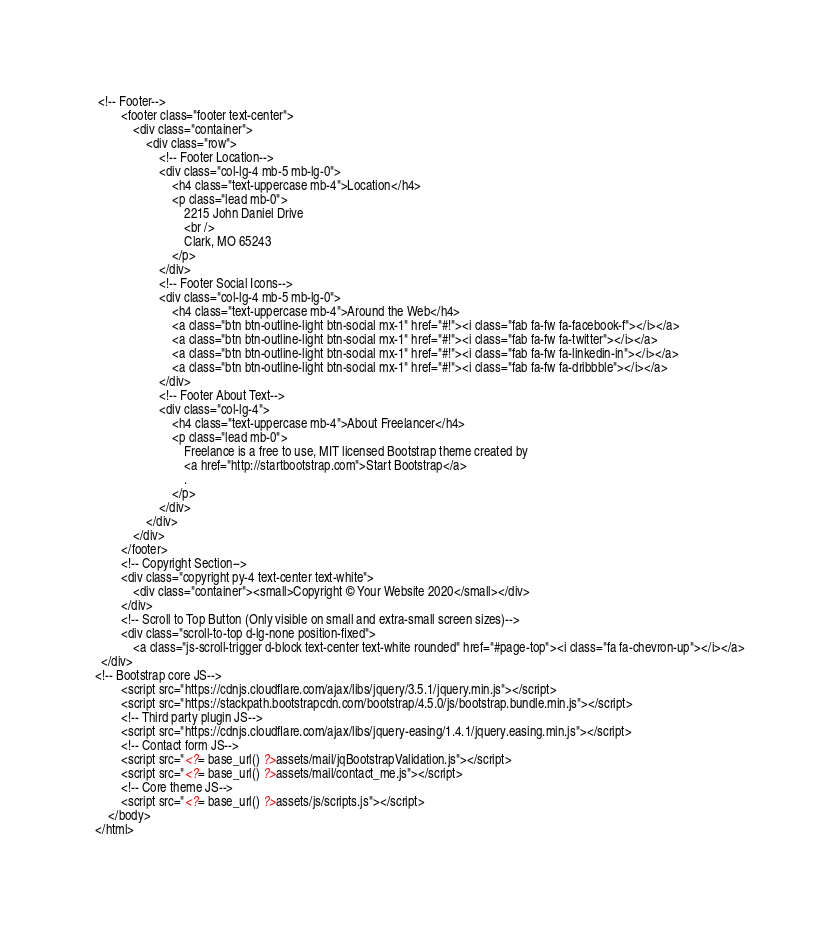Convert code to text. <code><loc_0><loc_0><loc_500><loc_500><_PHP_> <!-- Footer-->
        <footer class="footer text-center">
            <div class="container">
                <div class="row">
                    <!-- Footer Location-->
                    <div class="col-lg-4 mb-5 mb-lg-0">
                        <h4 class="text-uppercase mb-4">Location</h4>
                        <p class="lead mb-0">
                            2215 John Daniel Drive
                            <br />
                            Clark, MO 65243
                        </p>
                    </div>
                    <!-- Footer Social Icons-->
                    <div class="col-lg-4 mb-5 mb-lg-0">
                        <h4 class="text-uppercase mb-4">Around the Web</h4>
                        <a class="btn btn-outline-light btn-social mx-1" href="#!"><i class="fab fa-fw fa-facebook-f"></i></a>
                        <a class="btn btn-outline-light btn-social mx-1" href="#!"><i class="fab fa-fw fa-twitter"></i></a>
                        <a class="btn btn-outline-light btn-social mx-1" href="#!"><i class="fab fa-fw fa-linkedin-in"></i></a>
                        <a class="btn btn-outline-light btn-social mx-1" href="#!"><i class="fab fa-fw fa-dribbble"></i></a>
                    </div>
                    <!-- Footer About Text-->
                    <div class="col-lg-4">
                        <h4 class="text-uppercase mb-4">About Freelancer</h4>
                        <p class="lead mb-0">
                            Freelance is a free to use, MIT licensed Bootstrap theme created by
                            <a href="http://startbootstrap.com">Start Bootstrap</a>
                            .
                        </p>
                    </div>
                </div>
            </div>
        </footer>
        <!-- Copyright Section-->
        <div class="copyright py-4 text-center text-white">
            <div class="container"><small>Copyright © Your Website 2020</small></div>
        </div>
        <!-- Scroll to Top Button (Only visible on small and extra-small screen sizes)-->
        <div class="scroll-to-top d-lg-none position-fixed">
            <a class="js-scroll-trigger d-block text-center text-white rounded" href="#page-top"><i class="fa fa-chevron-up"></i></a>
  </div>
<!-- Bootstrap core JS-->
        <script src="https://cdnjs.cloudflare.com/ajax/libs/jquery/3.5.1/jquery.min.js"></script>
        <script src="https://stackpath.bootstrapcdn.com/bootstrap/4.5.0/js/bootstrap.bundle.min.js"></script>
        <!-- Third party plugin JS-->
        <script src="https://cdnjs.cloudflare.com/ajax/libs/jquery-easing/1.4.1/jquery.easing.min.js"></script>
        <!-- Contact form JS-->
        <script src="<?= base_url() ?>assets/mail/jqBootstrapValidation.js"></script>
        <script src="<?= base_url() ?>assets/mail/contact_me.js"></script>
        <!-- Core theme JS-->
        <script src="<?= base_url() ?>assets/js/scripts.js"></script>
    </body>
</html></code> 